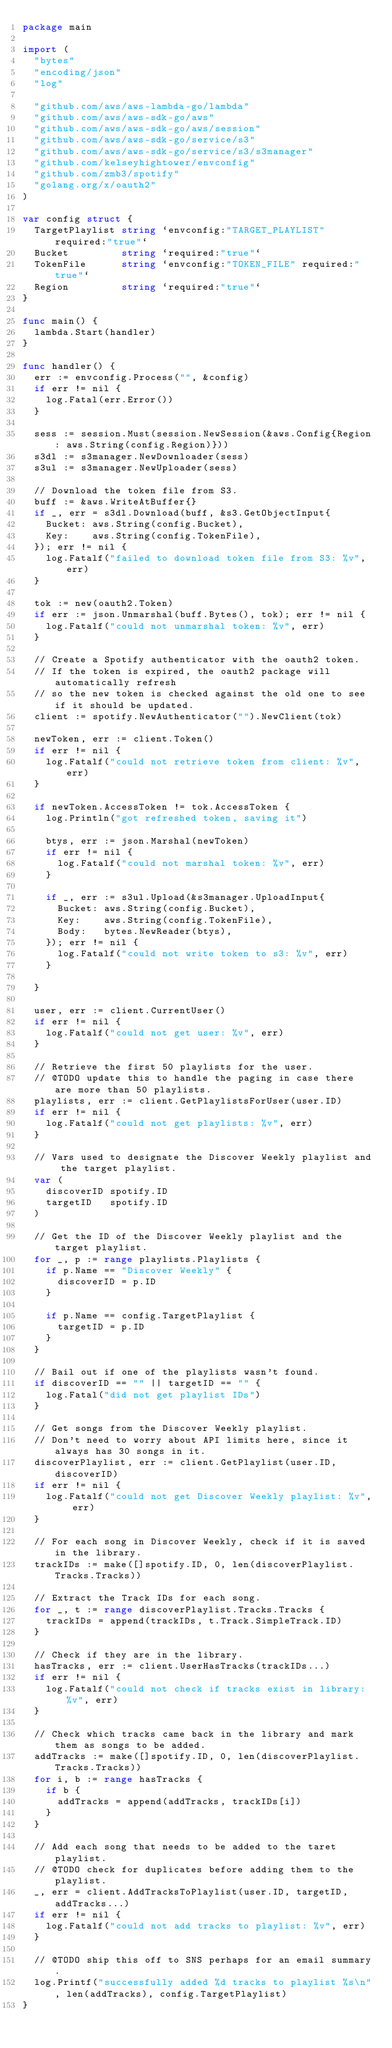Convert code to text. <code><loc_0><loc_0><loc_500><loc_500><_Go_>package main

import (
	"bytes"
	"encoding/json"
	"log"

	"github.com/aws/aws-lambda-go/lambda"
	"github.com/aws/aws-sdk-go/aws"
	"github.com/aws/aws-sdk-go/aws/session"
	"github.com/aws/aws-sdk-go/service/s3"
	"github.com/aws/aws-sdk-go/service/s3/s3manager"
	"github.com/kelseyhightower/envconfig"
	"github.com/zmb3/spotify"
	"golang.org/x/oauth2"
)

var config struct {
	TargetPlaylist string `envconfig:"TARGET_PLAYLIST" required:"true"`
	Bucket         string `required:"true"`
	TokenFile      string `envconfig:"TOKEN_FILE" required:"true"`
	Region         string `required:"true"`
}

func main() {
	lambda.Start(handler)
}

func handler() {
	err := envconfig.Process("", &config)
	if err != nil {
		log.Fatal(err.Error())
	}

	sess := session.Must(session.NewSession(&aws.Config{Region: aws.String(config.Region)}))
	s3dl := s3manager.NewDownloader(sess)
	s3ul := s3manager.NewUploader(sess)

	// Download the token file from S3.
	buff := &aws.WriteAtBuffer{}
	if _, err = s3dl.Download(buff, &s3.GetObjectInput{
		Bucket: aws.String(config.Bucket),
		Key:    aws.String(config.TokenFile),
	}); err != nil {
		log.Fatalf("failed to download token file from S3: %v", err)
	}

	tok := new(oauth2.Token)
	if err := json.Unmarshal(buff.Bytes(), tok); err != nil {
		log.Fatalf("could not unmarshal token: %v", err)
	}

	// Create a Spotify authenticator with the oauth2 token.
	// If the token is expired, the oauth2 package will automatically refresh
	// so the new token is checked against the old one to see if it should be updated.
	client := spotify.NewAuthenticator("").NewClient(tok)

	newToken, err := client.Token()
	if err != nil {
		log.Fatalf("could not retrieve token from client: %v", err)
	}

	if newToken.AccessToken != tok.AccessToken {
		log.Println("got refreshed token, saving it")

		btys, err := json.Marshal(newToken)
		if err != nil {
			log.Fatalf("could not marshal token: %v", err)
		}

		if _, err := s3ul.Upload(&s3manager.UploadInput{
			Bucket: aws.String(config.Bucket),
			Key:    aws.String(config.TokenFile),
			Body:   bytes.NewReader(btys),
		}); err != nil {
			log.Fatalf("could not write token to s3: %v", err)
		}

	}

	user, err := client.CurrentUser()
	if err != nil {
		log.Fatalf("could not get user: %v", err)
	}

	// Retrieve the first 50 playlists for the user.
	// @TODO update this to handle the paging in case there are more than 50 playlists.
	playlists, err := client.GetPlaylistsForUser(user.ID)
	if err != nil {
		log.Fatalf("could not get playlists: %v", err)
	}

	// Vars used to designate the Discover Weekly playlist and the target playlist.
	var (
		discoverID spotify.ID
		targetID   spotify.ID
	)

	// Get the ID of the Discover Weekly playlist and the target playlist.
	for _, p := range playlists.Playlists {
		if p.Name == "Discover Weekly" {
			discoverID = p.ID
		}

		if p.Name == config.TargetPlaylist {
			targetID = p.ID
		}
	}

	// Bail out if one of the playlists wasn't found.
	if discoverID == "" || targetID == "" {
		log.Fatal("did not get playlist IDs")
	}

	// Get songs from the Discover Weekly playlist.
	// Don't need to worry about API limits here, since it always has 30 songs in it.
	discoverPlaylist, err := client.GetPlaylist(user.ID, discoverID)
	if err != nil {
		log.Fatalf("could not get Discover Weekly playlist: %v", err)
	}

	// For each song in Discover Weekly, check if it is saved in the library.
	trackIDs := make([]spotify.ID, 0, len(discoverPlaylist.Tracks.Tracks))

	// Extract the Track IDs for each song.
	for _, t := range discoverPlaylist.Tracks.Tracks {
		trackIDs = append(trackIDs, t.Track.SimpleTrack.ID)
	}

	// Check if they are in the library.
	hasTracks, err := client.UserHasTracks(trackIDs...)
	if err != nil {
		log.Fatalf("could not check if tracks exist in library: %v", err)
	}

	// Check which tracks came back in the library and mark them as songs to be added.
	addTracks := make([]spotify.ID, 0, len(discoverPlaylist.Tracks.Tracks))
	for i, b := range hasTracks {
		if b {
			addTracks = append(addTracks, trackIDs[i])
		}
	}

	// Add each song that needs to be added to the taret playlist.
	// @TODO check for duplicates before adding them to the playlist.
	_, err = client.AddTracksToPlaylist(user.ID, targetID, addTracks...)
	if err != nil {
		log.Fatalf("could not add tracks to playlist: %v", err)
	}

	// @TODO ship this off to SNS perhaps for an email summary.
	log.Printf("successfully added %d tracks to playlist %s\n", len(addTracks), config.TargetPlaylist)
}
</code> 